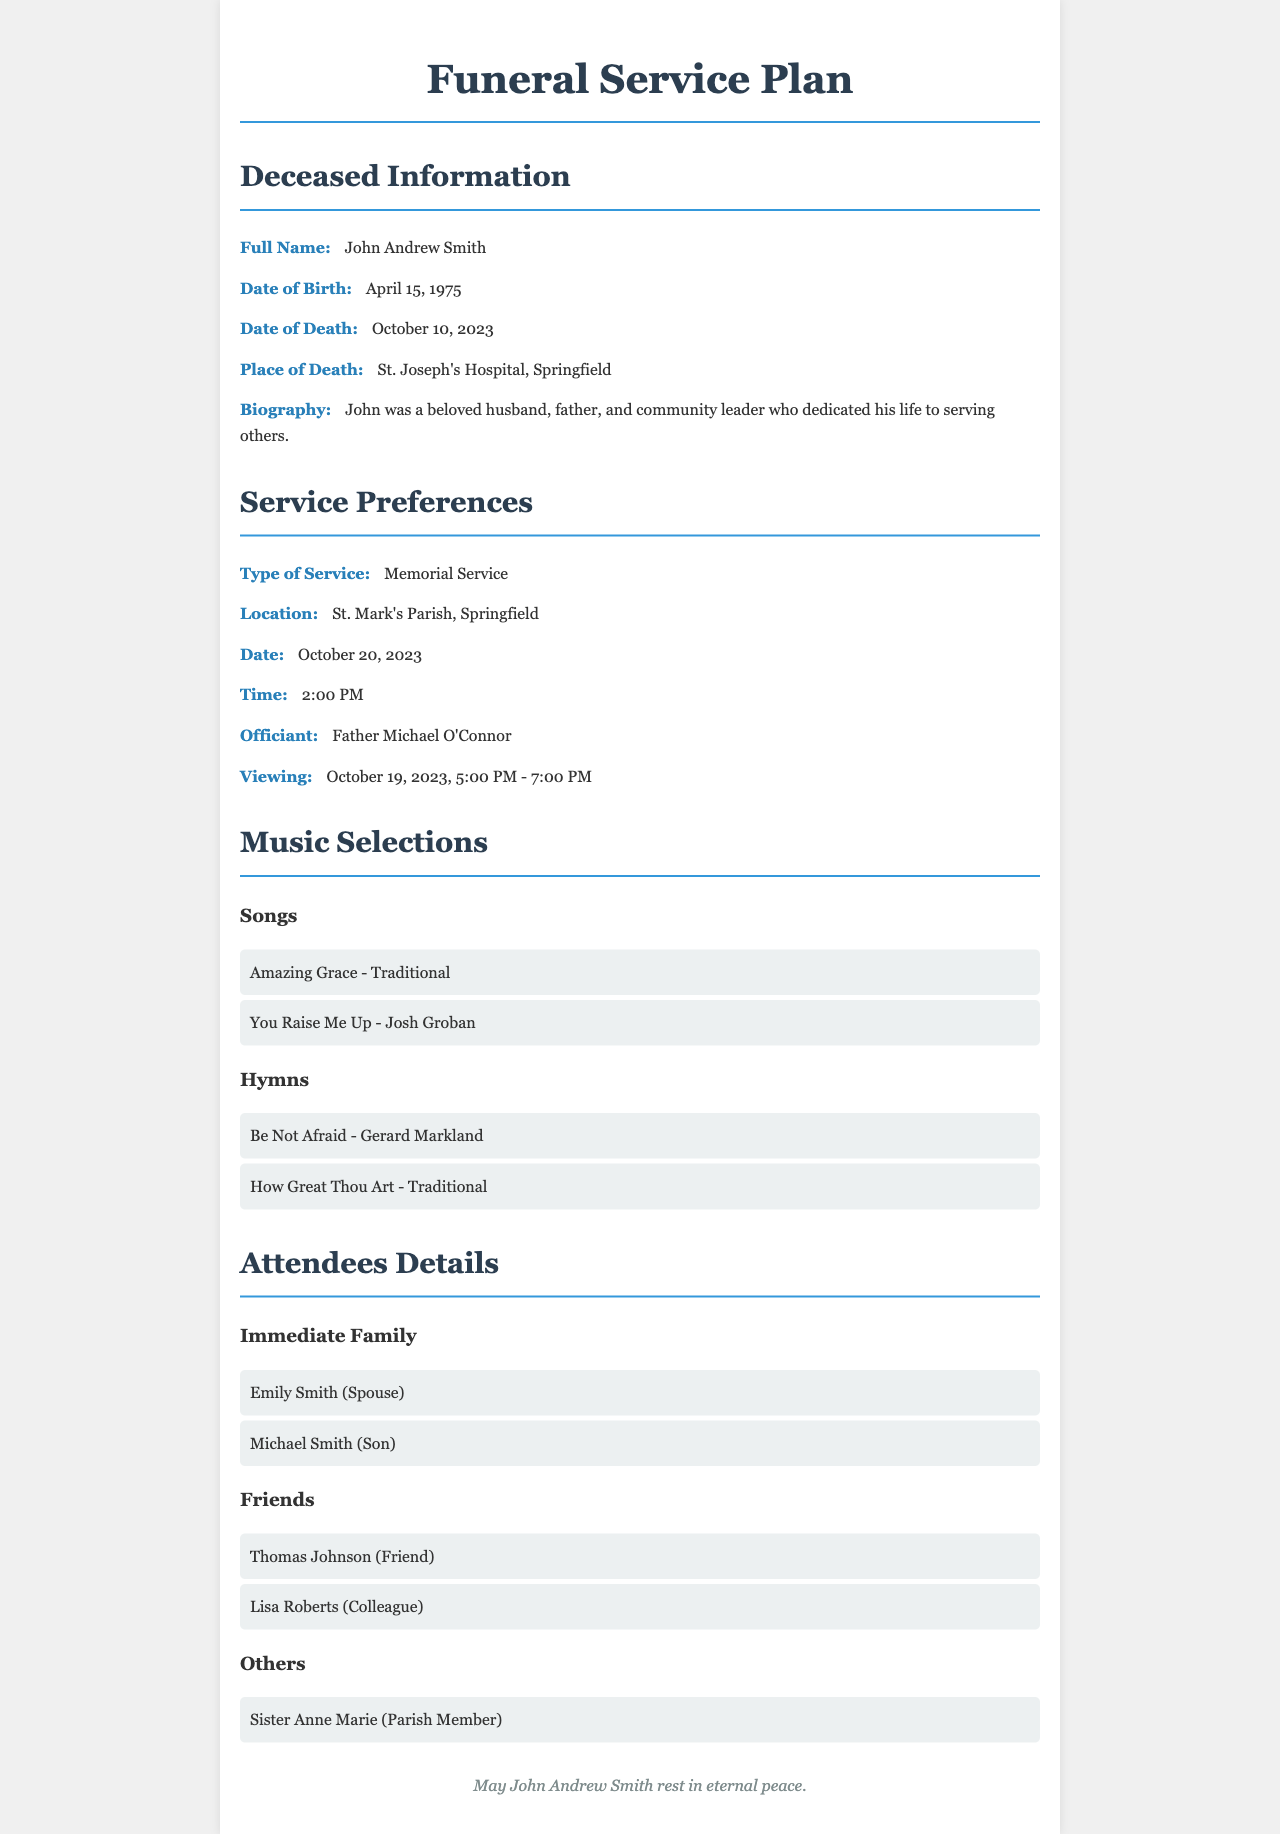What is the full name of the deceased? The full name is provided in the deceased information section of the document.
Answer: John Andrew Smith What is the date of death? The date of death is mentioned under the deceased information section.
Answer: October 10, 2023 Where is the memorial service located? The location for the service can be found in the service preferences section of the document.
Answer: St. Mark's Parish, Springfield Who is officiating the service? The officiant is listed in the service preferences section of the document.
Answer: Father Michael O'Connor What are the hymns selected for the service? The hymns are specifically mentioned in the music selections section of the document.
Answer: Be Not Afraid, How Great Thou Art How many immediate family members are listed? This can be counted from the attendees details section in the document.
Answer: 2 What time is the viewing scheduled? The viewing time is provided in the service preferences section.
Answer: October 19, 2023, 5:00 PM - 7:00 PM Who is listed as a friend among the attendees? Friends are identified in the attendees details section of the document.
Answer: Thomas Johnson What is the date of the memorial service? This date is specified in the service preferences section of the document.
Answer: October 20, 2023 